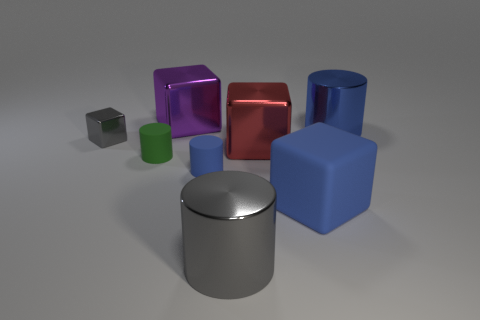Subtract 1 cylinders. How many cylinders are left? 3 Add 2 big blue things. How many objects exist? 10 Subtract 0 red balls. How many objects are left? 8 Subtract all tiny gray objects. Subtract all matte blocks. How many objects are left? 6 Add 4 metal cylinders. How many metal cylinders are left? 6 Add 3 tiny blue matte cubes. How many tiny blue matte cubes exist? 3 